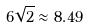Convert formula to latex. <formula><loc_0><loc_0><loc_500><loc_500>6 \sqrt { 2 } \approx 8 . 4 9</formula> 